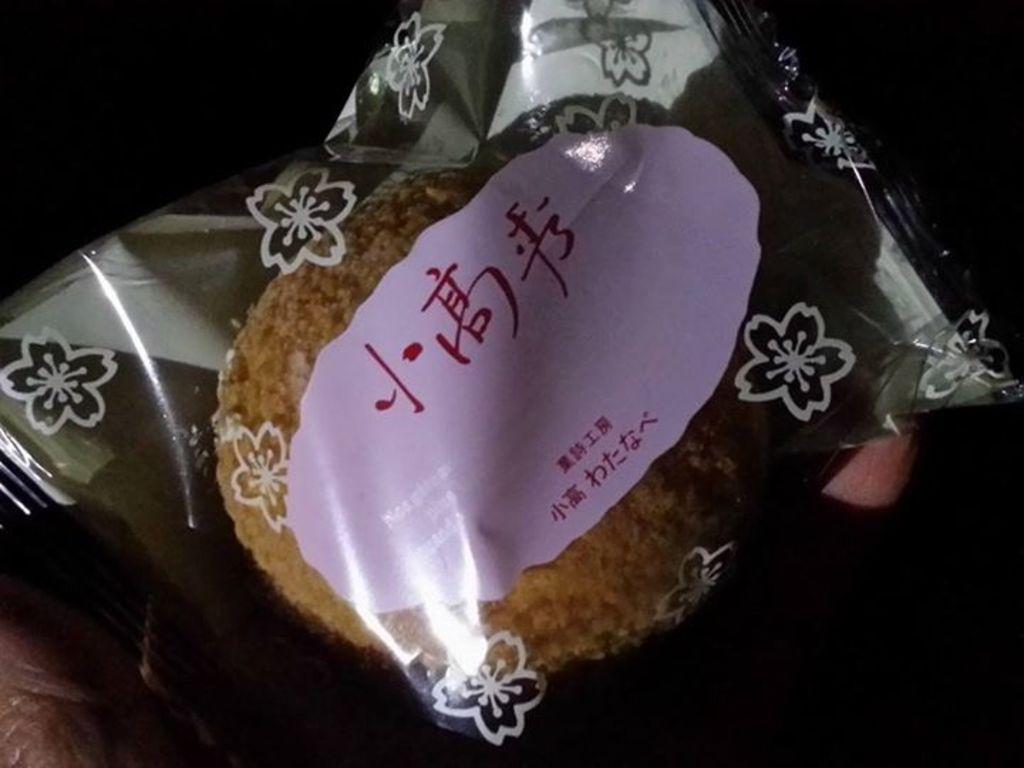Can you describe this image briefly? This picture shows some food in polythene cover and we see text on the cover. 